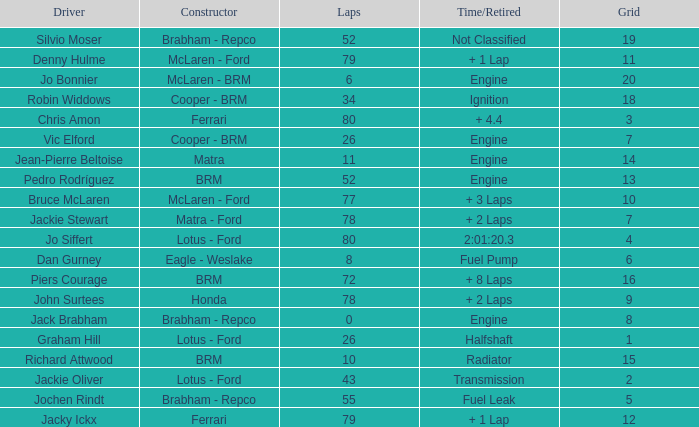When the driver richard attwood has a constructor of brm, what is the number of laps? 10.0. 